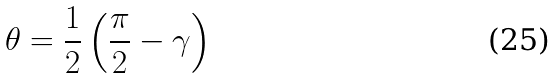Convert formula to latex. <formula><loc_0><loc_0><loc_500><loc_500>\theta = \frac { 1 } { 2 } \left ( \frac { \pi } { 2 } - \gamma \right )</formula> 